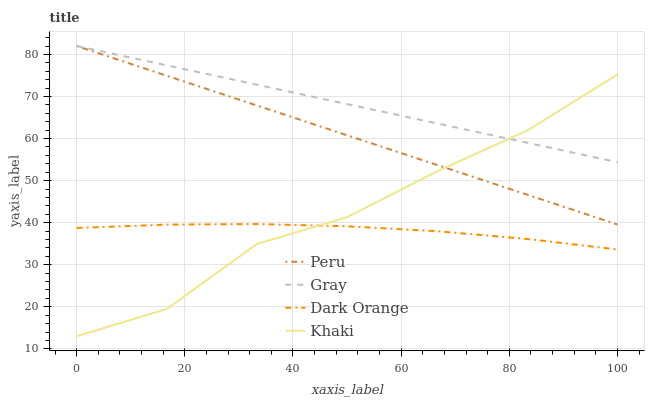Does Khaki have the minimum area under the curve?
Answer yes or no. No. Does Khaki have the maximum area under the curve?
Answer yes or no. No. Is Peru the smoothest?
Answer yes or no. No. Is Peru the roughest?
Answer yes or no. No. Does Peru have the lowest value?
Answer yes or no. No. Does Khaki have the highest value?
Answer yes or no. No. Is Dark Orange less than Gray?
Answer yes or no. Yes. Is Peru greater than Dark Orange?
Answer yes or no. Yes. Does Dark Orange intersect Gray?
Answer yes or no. No. 